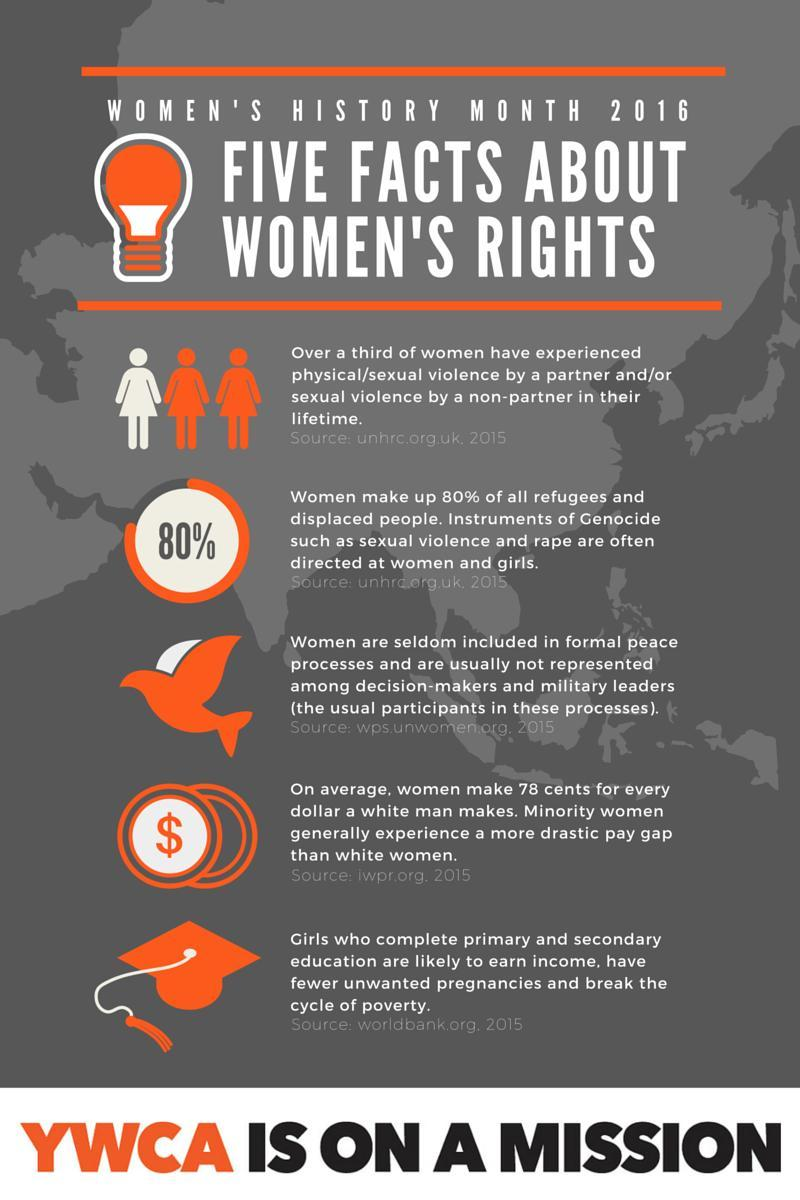Who are mostly represented in peace processes and decision-making processes, men or women?
Answer the question with a short phrase. Men Who are more susceptible to unwanted pregnancies and poverty, educated girls or uneducated girls? Uneducated girls What percentage of refugees and displaced people are "not"  women? 20% Out of every three women 'how many' have experienced physical violence? 1 Which currency symbol is shown in the image - pound, rupee, or dollar? Dollar Who are paid more, white women or minority women? Minority women 